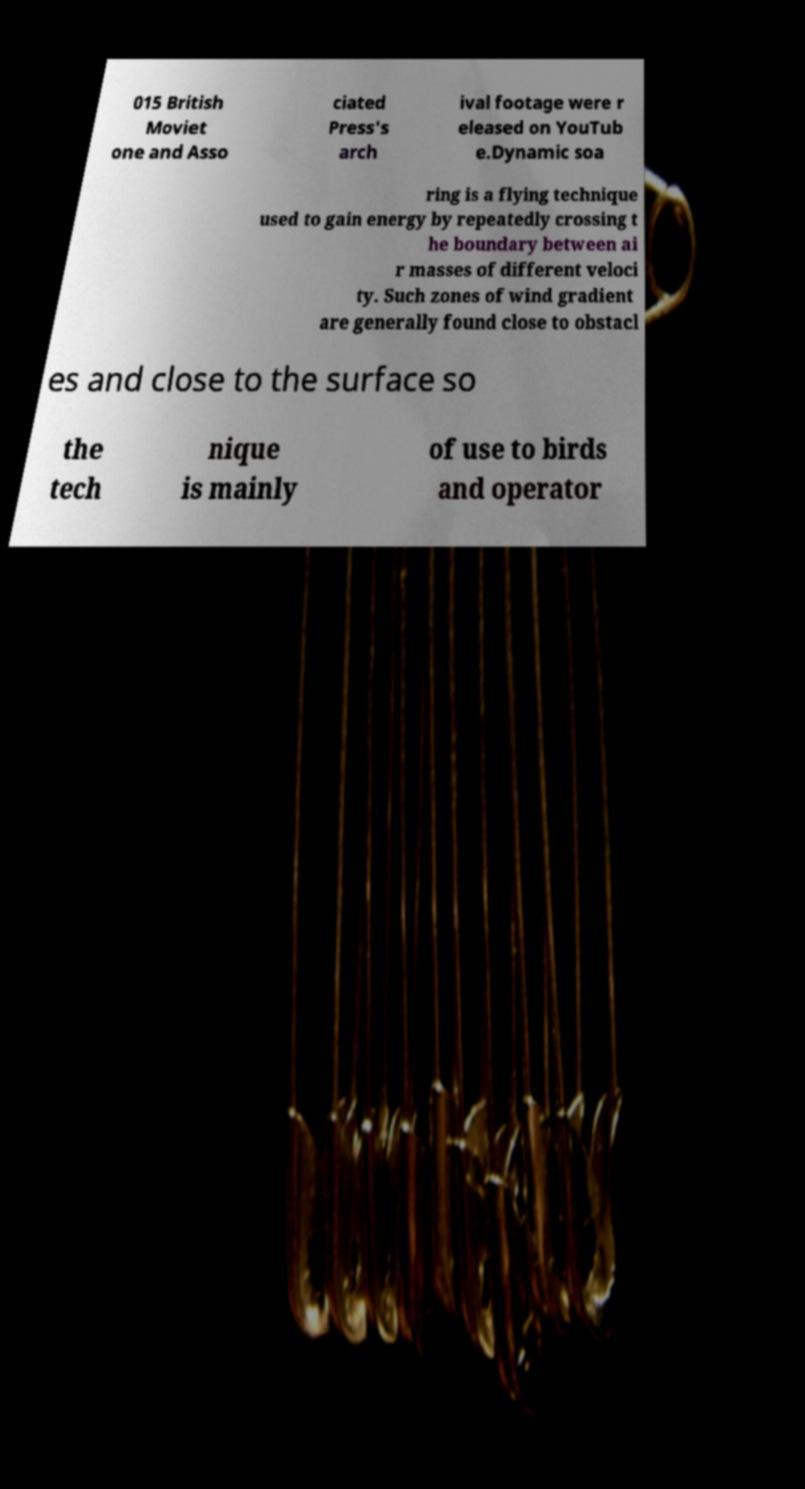Can you accurately transcribe the text from the provided image for me? 015 British Moviet one and Asso ciated Press's arch ival footage were r eleased on YouTub e.Dynamic soa ring is a flying technique used to gain energy by repeatedly crossing t he boundary between ai r masses of different veloci ty. Such zones of wind gradient are generally found close to obstacl es and close to the surface so the tech nique is mainly of use to birds and operator 